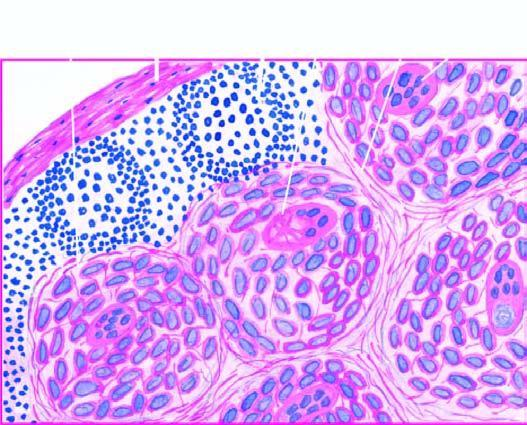re gamna-gandy body non-caseating epithelioid cell granulomas which have paucity of lymphocytes?
Answer the question using a single word or phrase. No 